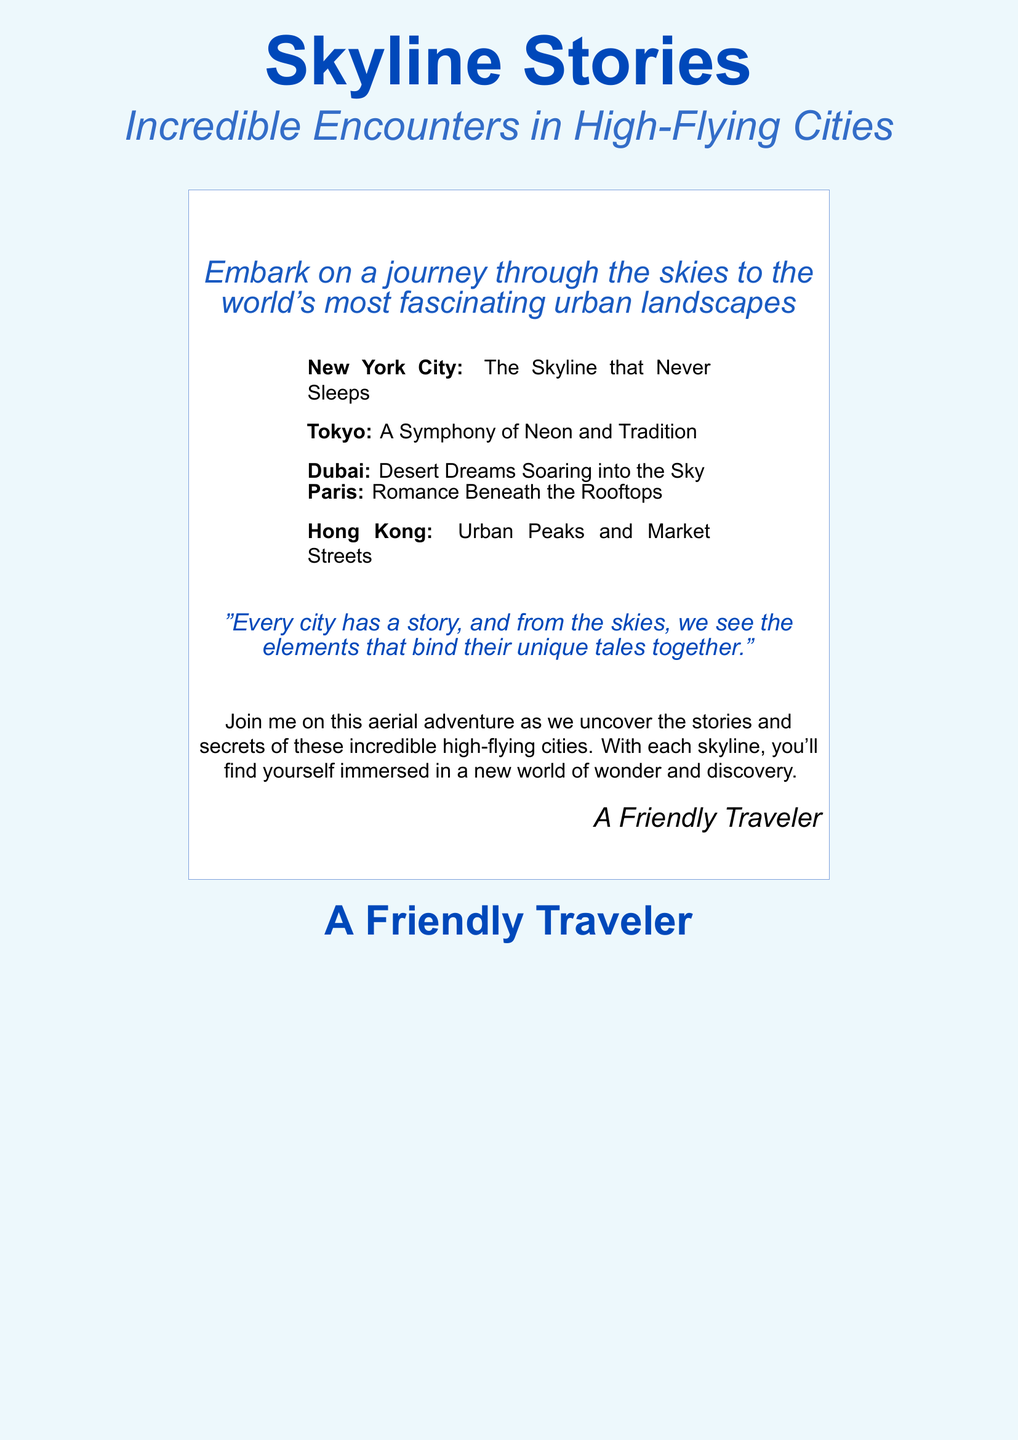What is the title of the book? The title "Skyline Stories" is prominently displayed at the top of the document.
Answer: Skyline Stories What are the subtitle words of the book? The subtitle is described right under the title, providing additional context.
Answer: Incredible Encounters in High-Flying Cities Which city is associated with "The Skyline that Never Sleeps"? The book lists New York City as a notable skyline in its content.
Answer: New York City What does the document suggest about every city? The document highlights a unique perspective on cities based on their stories and elements.
Answer: Every city has a story Who is the author or narrator of this book? The author is mentioned in the closing statement of the document.
Answer: A Friendly Traveler How many cities are mentioned in the book? There are five cities explicitly listed in the document.
Answer: Five What color is primarily used in the background of the book cover? The background color is described as sky blue with a specific RGB value.
Answer: Sky blue What type of journey does the book promise to the reader? The document describes the journey as an exploration of urban landscapes from the skies.
Answer: Aerial adventure 